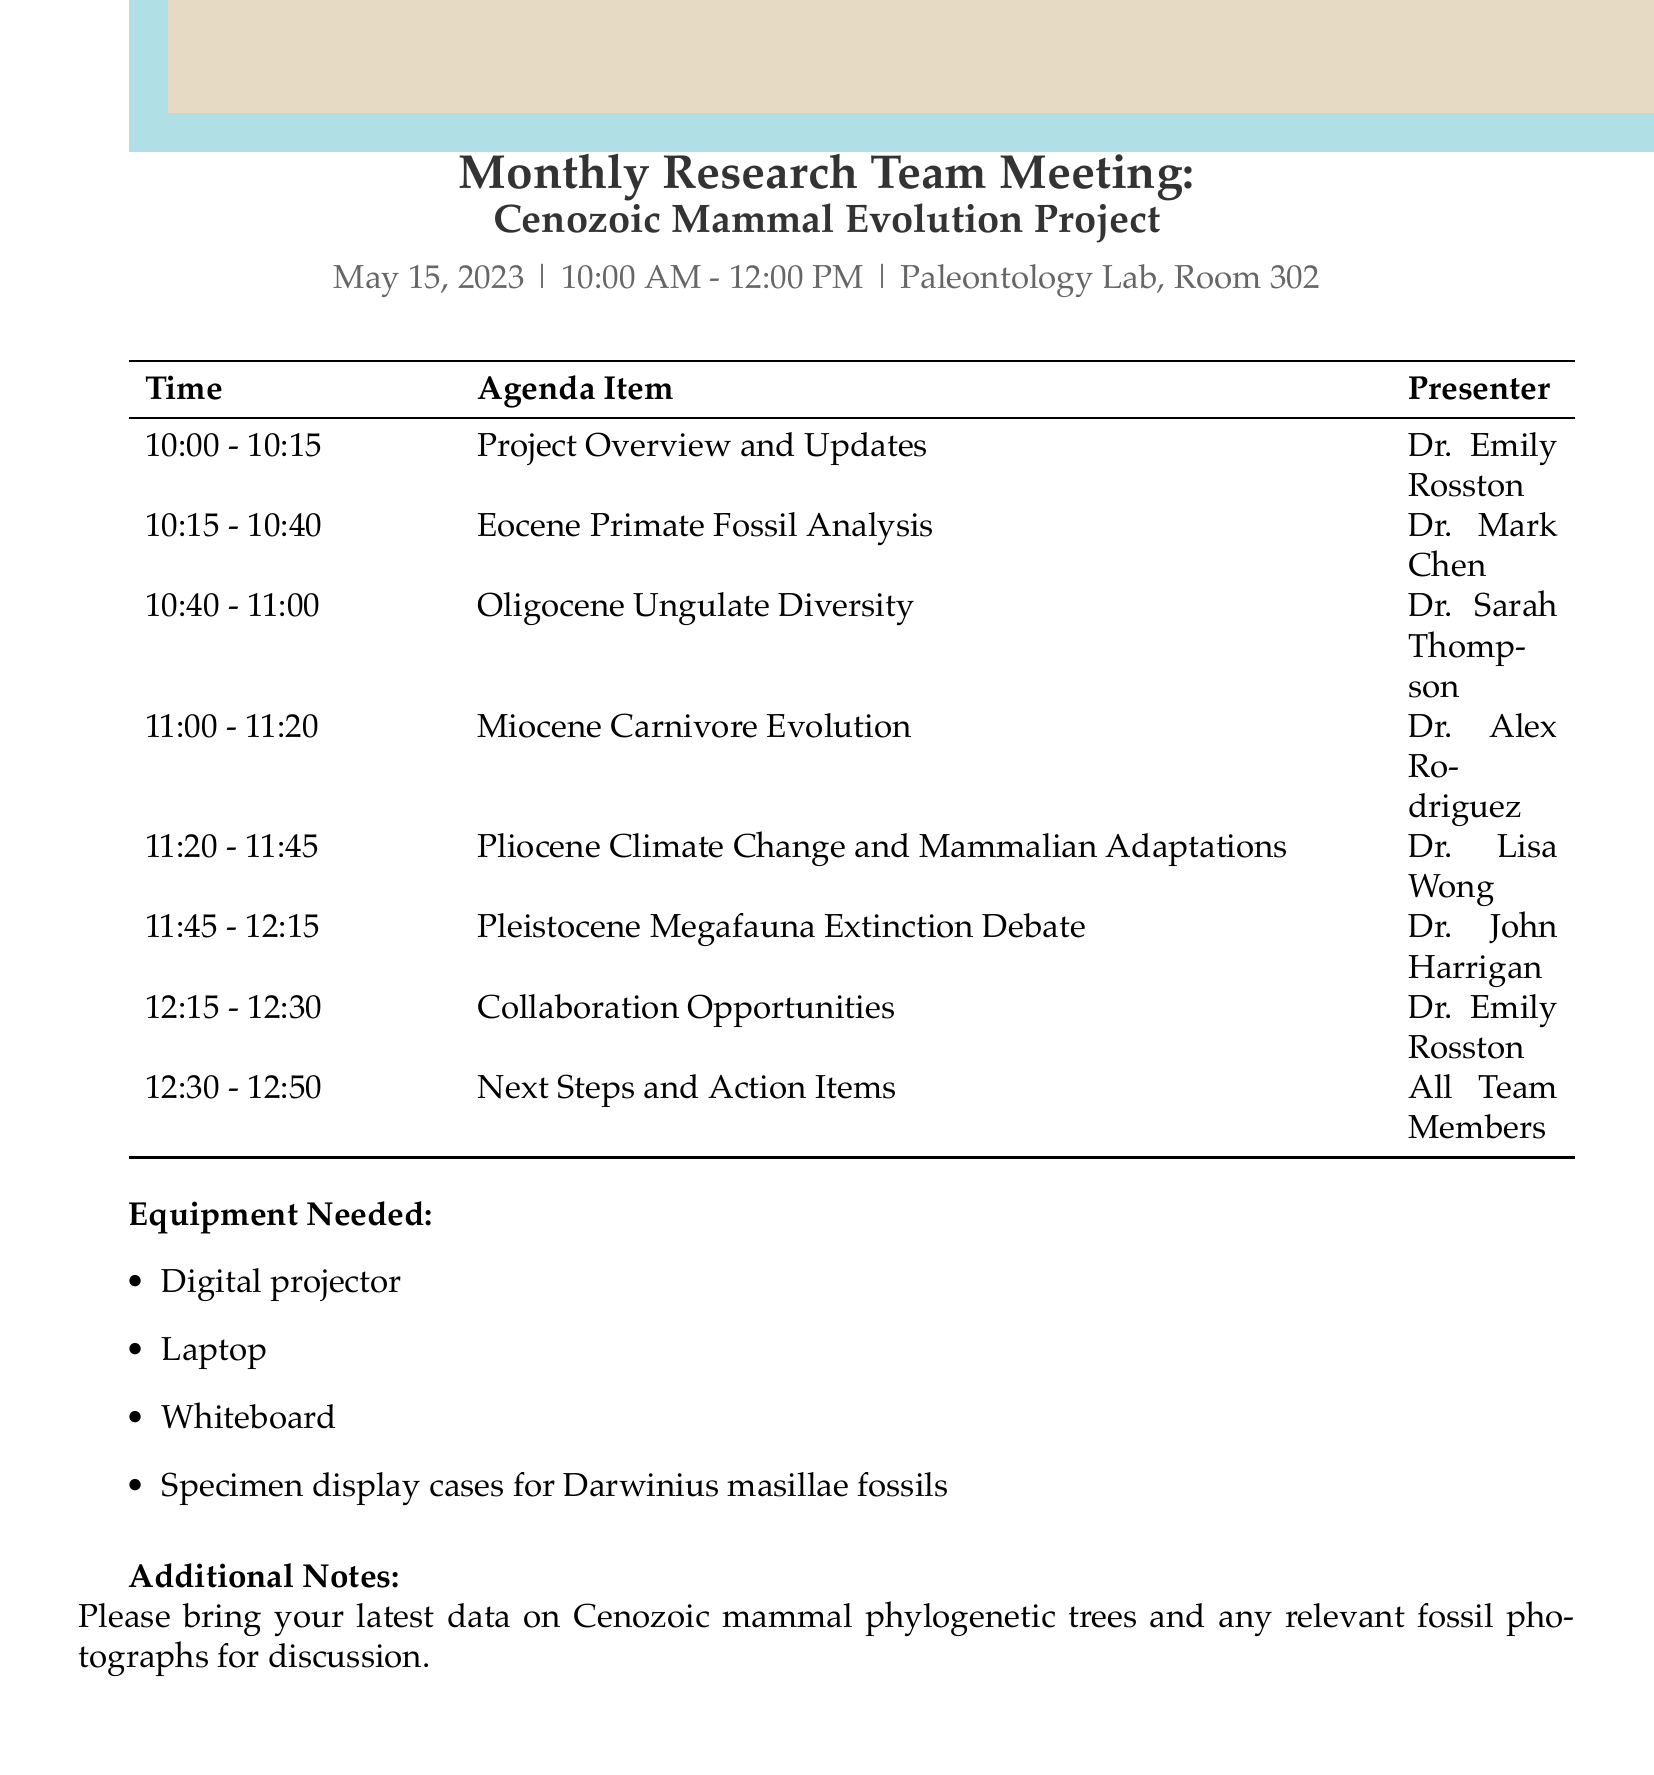What is the date of the meeting? The date of the meeting is explicitly stated in the document as May 15, 2023.
Answer: May 15, 2023 Who is presenting the section on Miocene Carnivore Evolution? The document lists the presenter for this section, which is Dr. Alex Rodriguez.
Answer: Dr. Alex Rodriguez How long is the presentation on Pleistocene Megafauna Extinction Debate scheduled for? The document specifies the duration of this presentation as 30 minutes.
Answer: 30 minutes What is the primary focus of the Eocene Primate Fossil Analysis? The details of the presentation indicate that the focus is on Darwinius masillae specimens.
Answer: Darwinius masillae specimens What equipment is needed for the meeting? The equipment section lists out necessary items, including a digital projector and a laptop.
Answer: Digital projector, Laptop Who is responsible for leading the discussion on Collaboration Opportunities? The agenda specifies that Dr. Emily Rosston will be leading this discussion.
Answer: Dr. Emily Rosston What kind of data should team members bring for discussion? The additional notes clearly state that team members are to bring data on Cenozoic mammal phylogenetic trees and fossil photographs.
Answer: Cenozoic mammal phylogenetic trees and fossil photographs What time does the Monthly Research Team Meeting start? The meeting's start time is clearly mentioned as 10:00 AM in the document.
Answer: 10:00 AM 